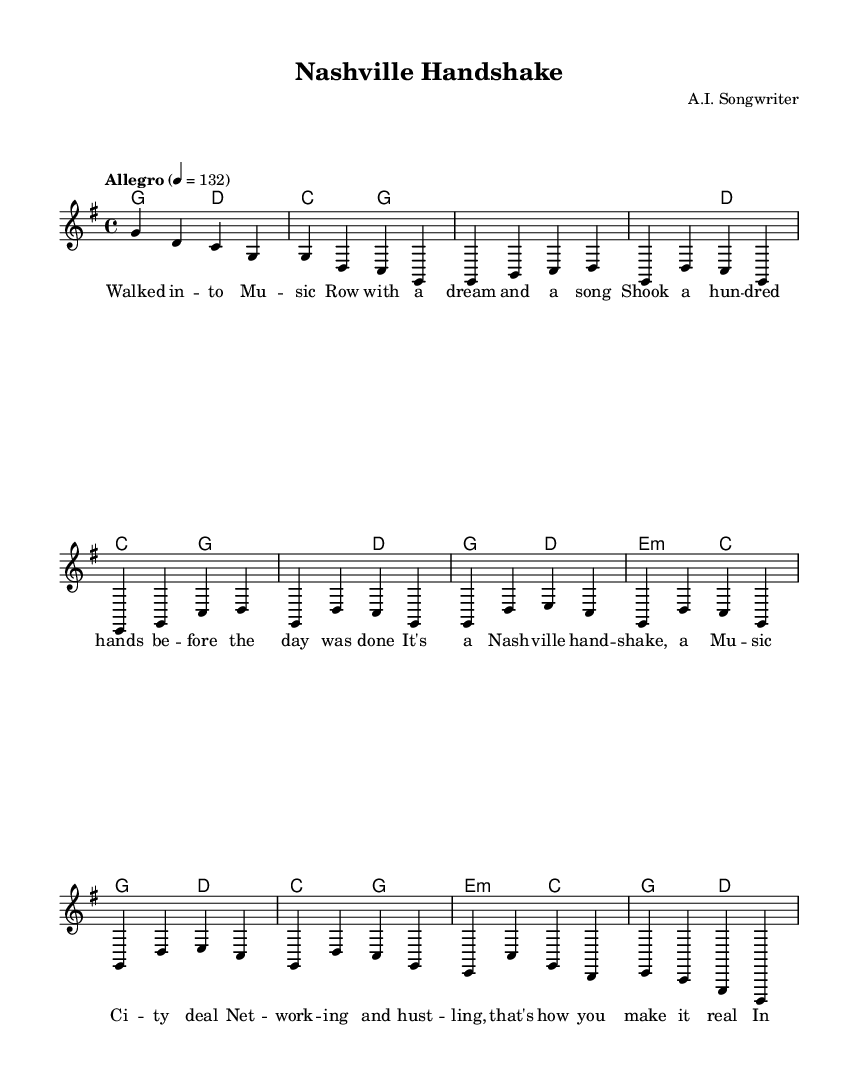What is the key signature of this music? The key signature is indicated at the beginning of the sheet music. It shows one sharp, which corresponds to G major.
Answer: G major What is the time signature of this music? The time signature is displayed at the beginning of the score. It is 4/4, which means there are four beats in each measure.
Answer: 4/4 What is the tempo marking of this piece? The tempo is stated above the staff, specified as "Allegro". The number 132 indicates the beats per minute.
Answer: Allegro, 132 How many measures are in the intro? The intro section is notated at the beginning of the piece and consists of two measures (4 beats each, totaling 8 beats).
Answer: 2 What is the first lyric line of the verse? The lyrics for the verse section are notated beneath the melody notes starting with "Walked in -- to Mu -- sic Row". The first line identifies the initial lyrics.
Answer: Walked in -- to Mu -- sic Row with a dream and a song Which chord is played during the first verse line? The first verse line starts with the melody in the key of G major, which corresponds to the chord G (as seen in the harmonies).
Answer: G What core theme does the chorus emphasize? The chorus focuses on networking and relationships in the music industry, as indicated by the lyrics that emphasize "Nashville hand-shake" and "Net -- working and hust -- ling".
Answer: Networking 